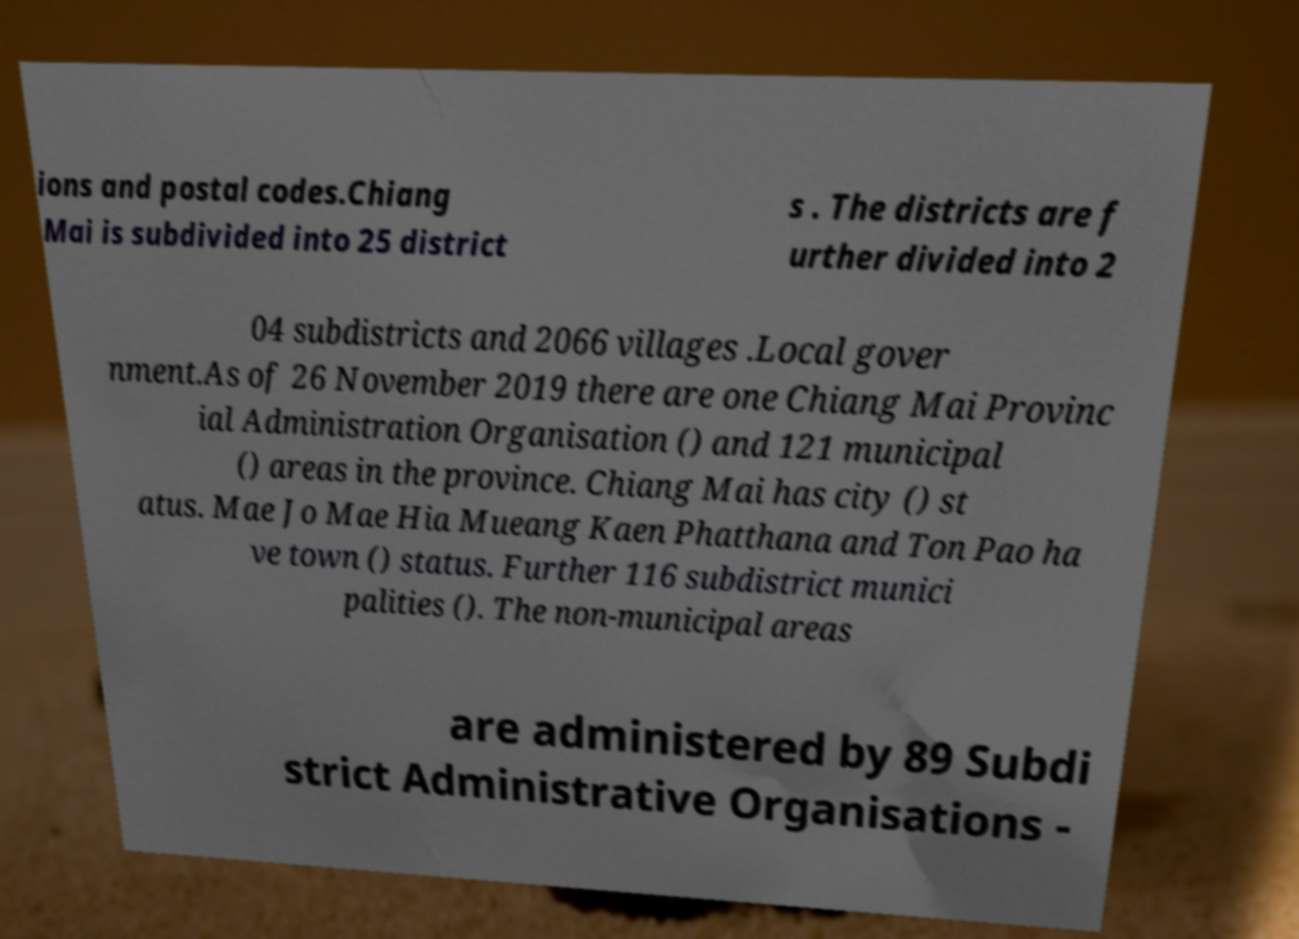What messages or text are displayed in this image? I need them in a readable, typed format. ions and postal codes.Chiang Mai is subdivided into 25 district s . The districts are f urther divided into 2 04 subdistricts and 2066 villages .Local gover nment.As of 26 November 2019 there are one Chiang Mai Provinc ial Administration Organisation () and 121 municipal () areas in the province. Chiang Mai has city () st atus. Mae Jo Mae Hia Mueang Kaen Phatthana and Ton Pao ha ve town () status. Further 116 subdistrict munici palities (). The non-municipal areas are administered by 89 Subdi strict Administrative Organisations - 